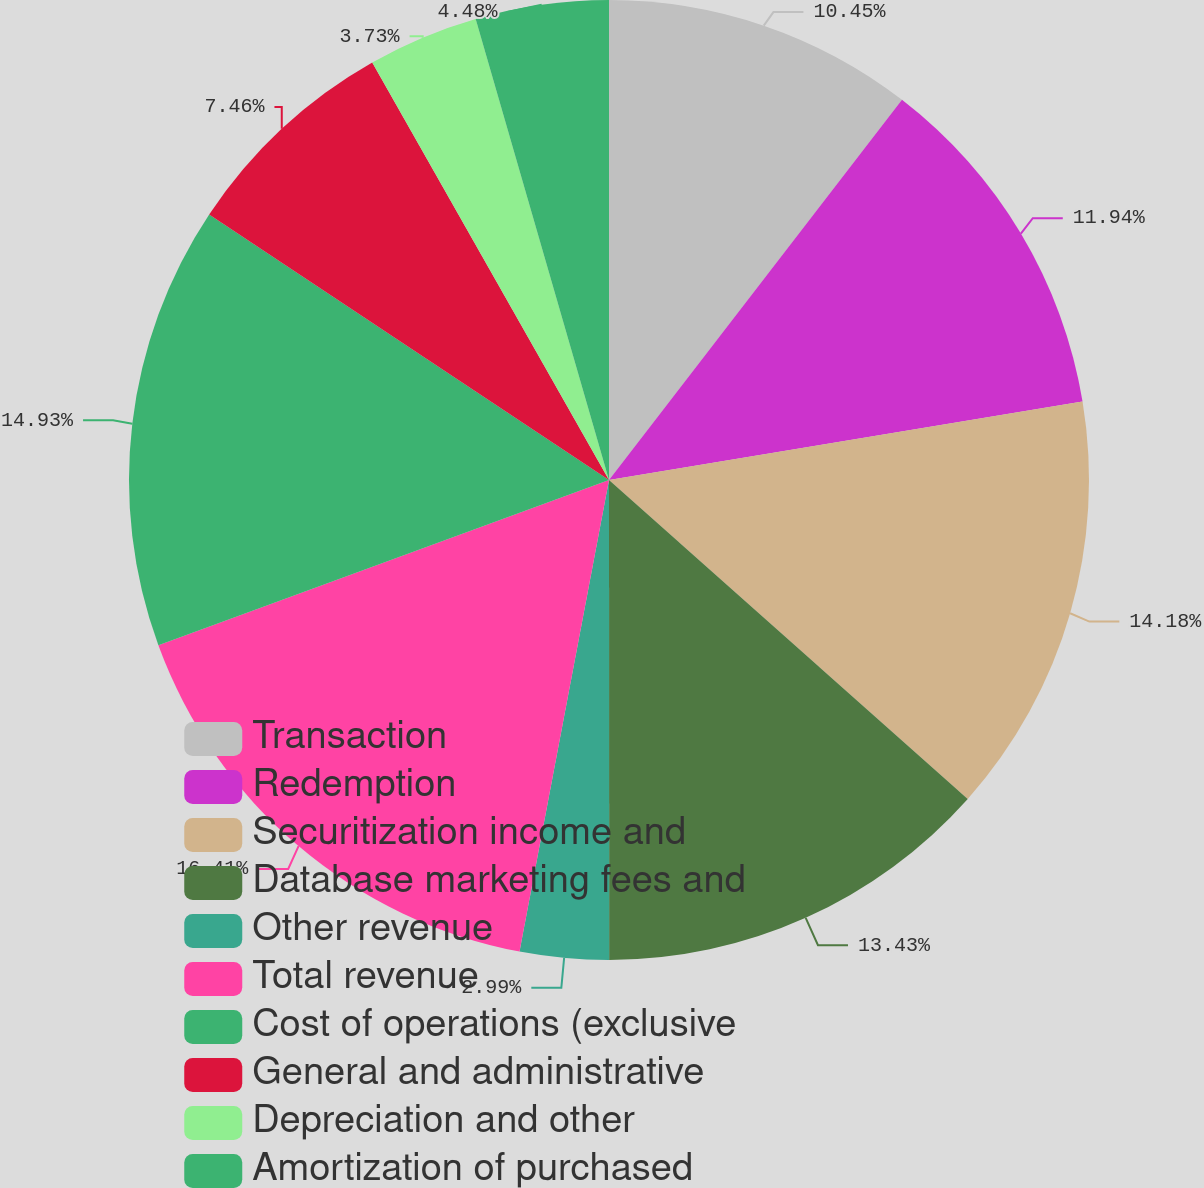<chart> <loc_0><loc_0><loc_500><loc_500><pie_chart><fcel>Transaction<fcel>Redemption<fcel>Securitization income and<fcel>Database marketing fees and<fcel>Other revenue<fcel>Total revenue<fcel>Cost of operations (exclusive<fcel>General and administrative<fcel>Depreciation and other<fcel>Amortization of purchased<nl><fcel>10.45%<fcel>11.94%<fcel>14.18%<fcel>13.43%<fcel>2.99%<fcel>16.42%<fcel>14.93%<fcel>7.46%<fcel>3.73%<fcel>4.48%<nl></chart> 